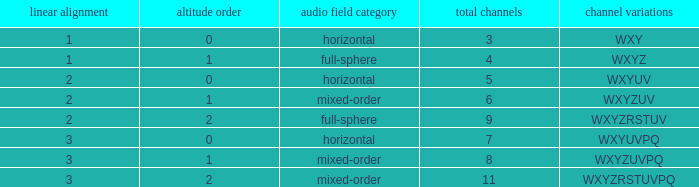If the height order is 1 and the soundfield type is mixed-order, what are all the channels? WXYZUV, WXYZUVPQ. 